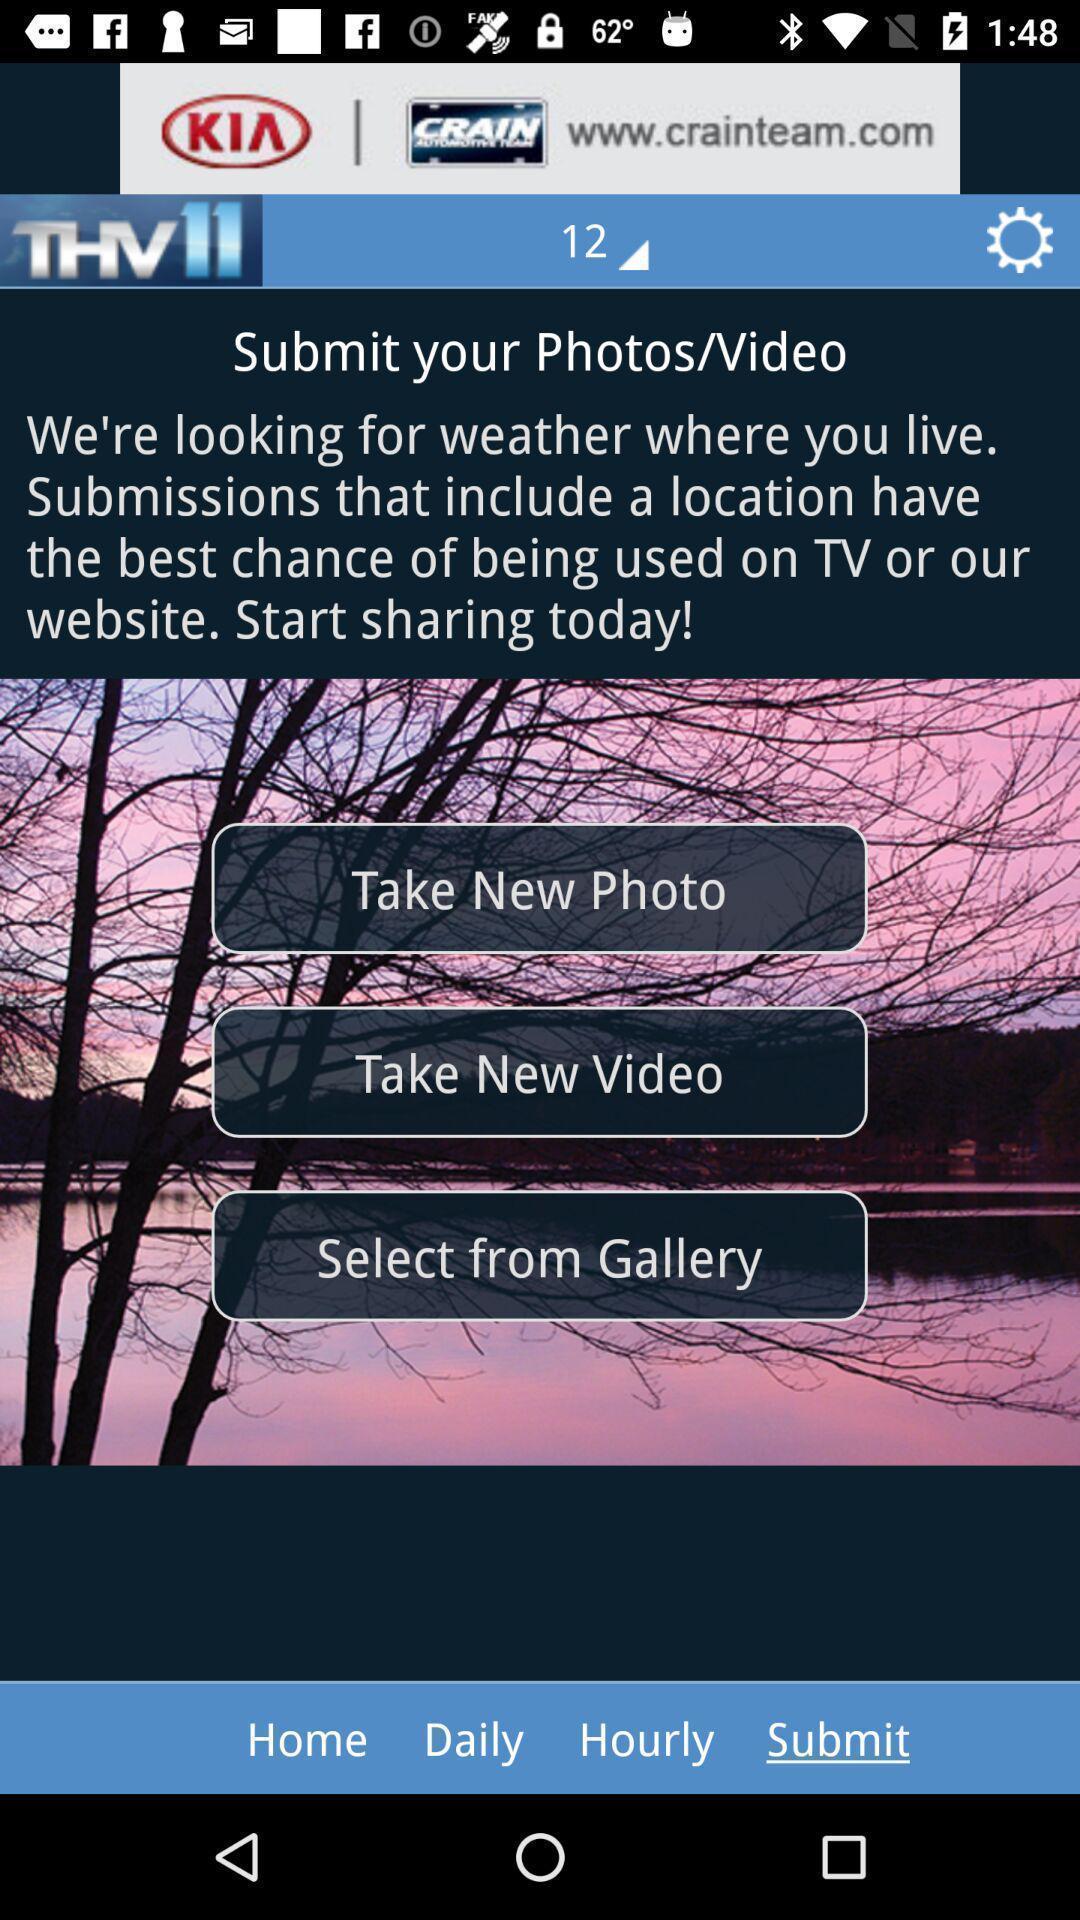Describe the visual elements of this screenshot. Submit photos or videos in thv. 